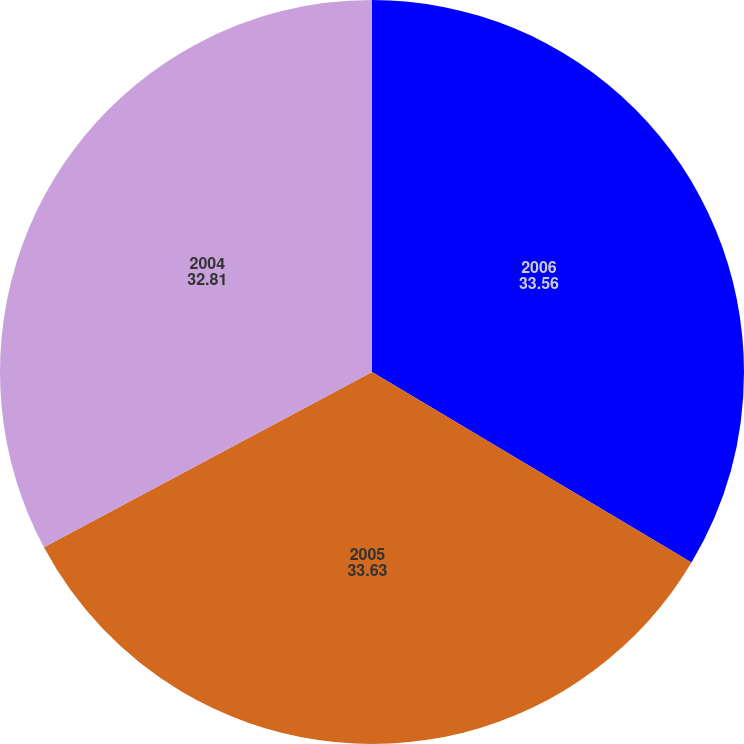<chart> <loc_0><loc_0><loc_500><loc_500><pie_chart><fcel>2006<fcel>2005<fcel>2004<nl><fcel>33.56%<fcel>33.63%<fcel>32.81%<nl></chart> 